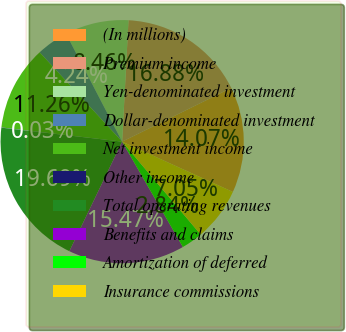Convert chart. <chart><loc_0><loc_0><loc_500><loc_500><pie_chart><fcel>(In millions)<fcel>Premium income<fcel>Yen-denominated investment<fcel>Dollar-denominated investment<fcel>Net investment income<fcel>Other income<fcel>Total operating revenues<fcel>Benefits and claims<fcel>Amortization of deferred<fcel>Insurance commissions<nl><fcel>14.07%<fcel>16.88%<fcel>8.46%<fcel>4.24%<fcel>11.26%<fcel>0.03%<fcel>19.69%<fcel>15.47%<fcel>2.84%<fcel>7.05%<nl></chart> 